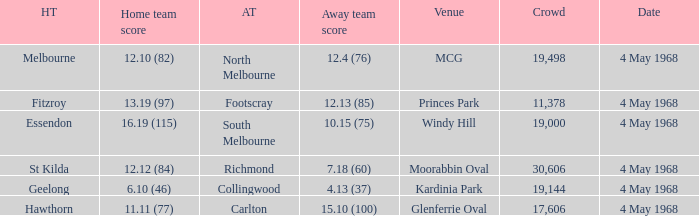Parse the full table. {'header': ['HT', 'Home team score', 'AT', 'Away team score', 'Venue', 'Crowd', 'Date'], 'rows': [['Melbourne', '12.10 (82)', 'North Melbourne', '12.4 (76)', 'MCG', '19,498', '4 May 1968'], ['Fitzroy', '13.19 (97)', 'Footscray', '12.13 (85)', 'Princes Park', '11,378', '4 May 1968'], ['Essendon', '16.19 (115)', 'South Melbourne', '10.15 (75)', 'Windy Hill', '19,000', '4 May 1968'], ['St Kilda', '12.12 (84)', 'Richmond', '7.18 (60)', 'Moorabbin Oval', '30,606', '4 May 1968'], ['Geelong', '6.10 (46)', 'Collingwood', '4.13 (37)', 'Kardinia Park', '19,144', '4 May 1968'], ['Hawthorn', '11.11 (77)', 'Carlton', '15.10 (100)', 'Glenferrie Oval', '17,606', '4 May 1968']]} What home team played at MCG? North Melbourne. 